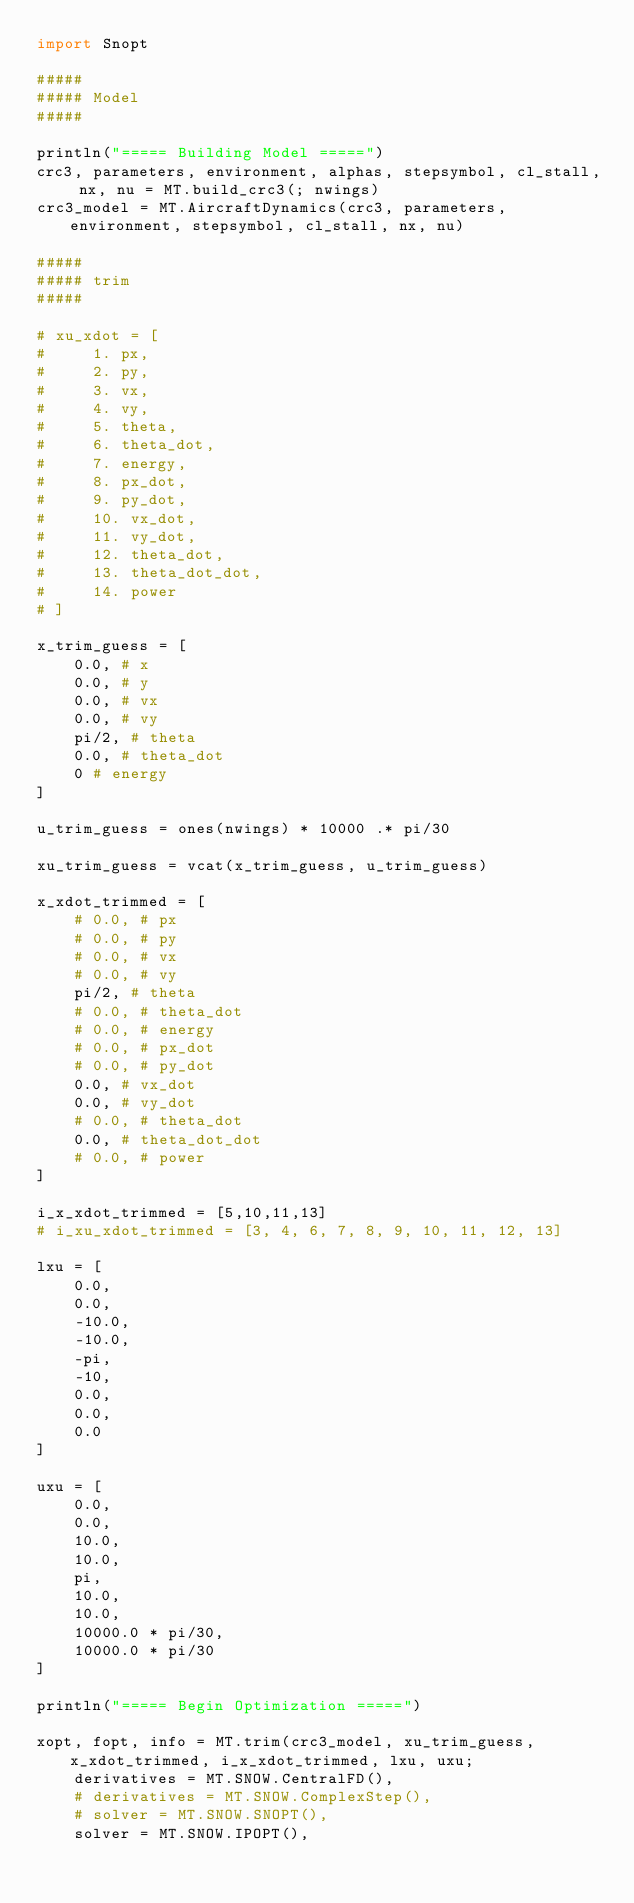<code> <loc_0><loc_0><loc_500><loc_500><_Julia_>import Snopt

#####
##### Model
#####

println("===== Building Model =====")
crc3, parameters, environment, alphas, stepsymbol, cl_stall, nx, nu = MT.build_crc3(; nwings)
crc3_model = MT.AircraftDynamics(crc3, parameters, environment, stepsymbol, cl_stall, nx, nu)

#####
##### trim
#####

# xu_xdot = [
#     1. px,
#     2. py,
#     3. vx,
#     4. vy,
#     5. theta,
#     6. theta_dot,
#     7. energy,
#     8. px_dot,
#     9. py_dot,
#     10. vx_dot,
#     11. vy_dot,
#     12. theta_dot,
#     13. theta_dot_dot,
#     14. power
# ]

x_trim_guess = [
    0.0, # x
    0.0, # y
    0.0, # vx
    0.0, # vy
    pi/2, # theta
    0.0, # theta_dot
    0 # energy
]

u_trim_guess = ones(nwings) * 10000 .* pi/30

xu_trim_guess = vcat(x_trim_guess, u_trim_guess)

x_xdot_trimmed = [
    # 0.0, # px
    # 0.0, # py
    # 0.0, # vx
    # 0.0, # vy
    pi/2, # theta
    # 0.0, # theta_dot
    # 0.0, # energy
    # 0.0, # px_dot
    # 0.0, # py_dot
    0.0, # vx_dot
    0.0, # vy_dot
    # 0.0, # theta_dot
    0.0, # theta_dot_dot
    # 0.0, # power
]

i_x_xdot_trimmed = [5,10,11,13]
# i_xu_xdot_trimmed = [3, 4, 6, 7, 8, 9, 10, 11, 12, 13]

lxu = [
    0.0,
    0.0,
    -10.0,
    -10.0,
    -pi,
    -10,
    0.0,
    0.0,
    0.0
]

uxu = [
    0.0,
    0.0,
    10.0,
    10.0,
    pi,
    10.0,
    10.0,
    10000.0 * pi/30,
    10000.0 * pi/30
]

println("===== Begin Optimization =====")

xopt, fopt, info = MT.trim(crc3_model, xu_trim_guess, x_xdot_trimmed, i_x_xdot_trimmed, lxu, uxu;
    derivatives = MT.SNOW.CentralFD(),
    # derivatives = MT.SNOW.ComplexStep(),
    # solver = MT.SNOW.SNOPT(),
    solver = MT.SNOW.IPOPT(),</code> 